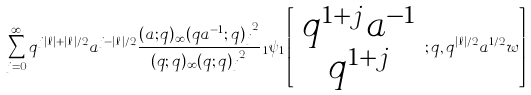Convert formula to latex. <formula><loc_0><loc_0><loc_500><loc_500>\sum _ { j = 0 } ^ { \infty } q ^ { j | \ell | + | \ell | / 2 } a ^ { j - | \ell | / 2 } \frac { ( a ; q ) _ { \infty } { ( q a ^ { - 1 } ; q ) _ { j } } ^ { 2 } } { ( q ; q ) _ { \infty } { ( q ; q ) _ { j } } ^ { 2 } } \, _ { 1 } \psi _ { 1 } \left [ \begin{array} { c } q ^ { 1 + j } a ^ { - 1 } \\ q ^ { 1 + j } \end{array} ; q , q ^ { | \ell | / 2 } a ^ { 1 / 2 } w \right ]</formula> 